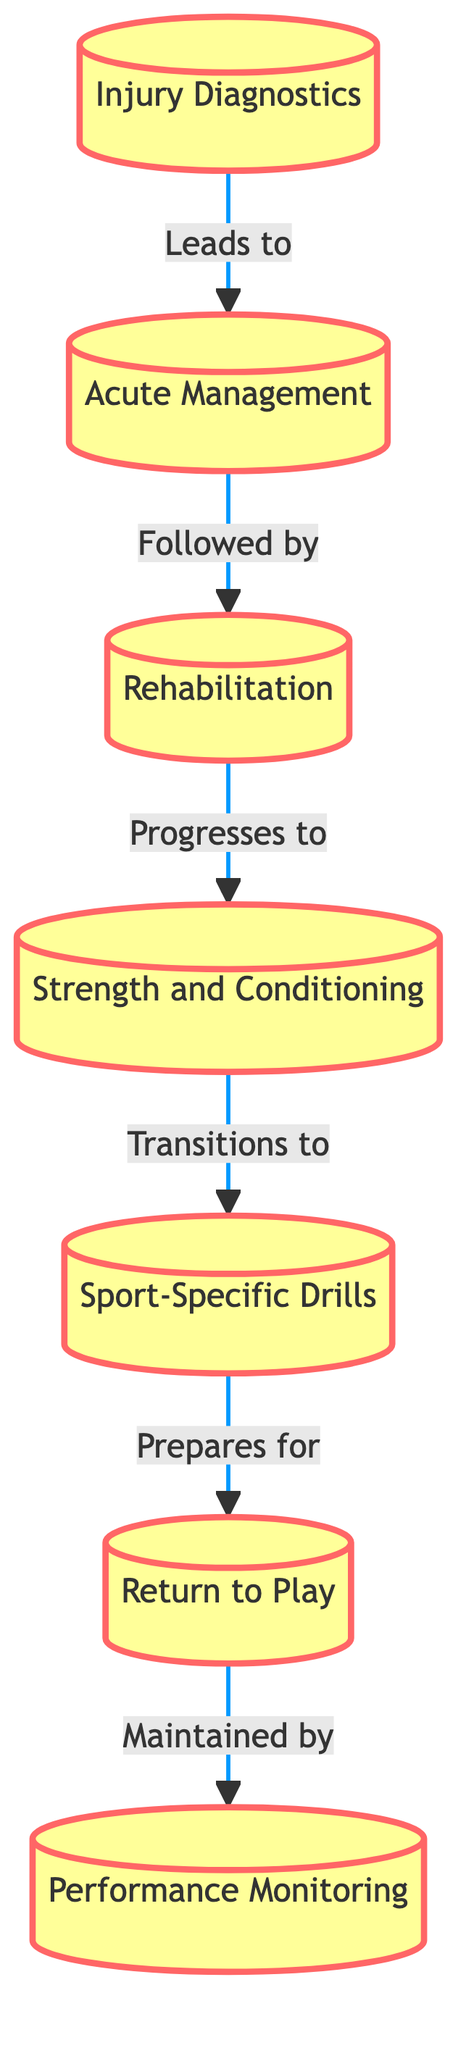What is the first phase in the injury recovery process? The diagram starts with the first node labeled "Injury Diagnostics," which is clearly marked as the initial phase.
Answer: Injury Diagnostics How many phases are there in total? By counting the individual phases listed in the diagram, we have seven distinct phases from "Injury Diagnostics" to "Performance Monitoring."
Answer: 7 What leads directly to the rehabilitation phase? The arrow from the "Acute Management" node points directly to the "Rehabilitation" phase, indicating that it is the phase that follows "Acute Management."
Answer: Acute Management What is the last phase of the recovery process? The final node in the diagram is labeled "Performance Monitoring". This indicates it is the last stage in the recovery process.
Answer: Performance Monitoring Which phase prepares for the return to play? The diagram specifies that "Sport-Specific Drills" prepares the athlete for the "Return to Play," as indicated by the arrow leading from one to the other.
Answer: Sport-Specific Drills What is the link between rehabilitation and strength conditioning? The flow of the diagram shows a direct progression from "Rehabilitation" to "Strength and Conditioning," meaning that rehabilitation leads into this phase.
Answer: Strength and Conditioning How does acute management transition to rehabilitation? The diagram indicates a direct flow from "Acute Management" to "Rehabilitation," which establishes that acute management is the preceding phase before rehabilitation can begin.
Answer: Rehabilitation What role does performance monitoring have in the recovery process? The diagram shows that "Performance Monitoring" is maintained by the "Return to Play" phase, indicating that performance is continuously monitored throughout this stage.
Answer: Maintained by Return to Play 